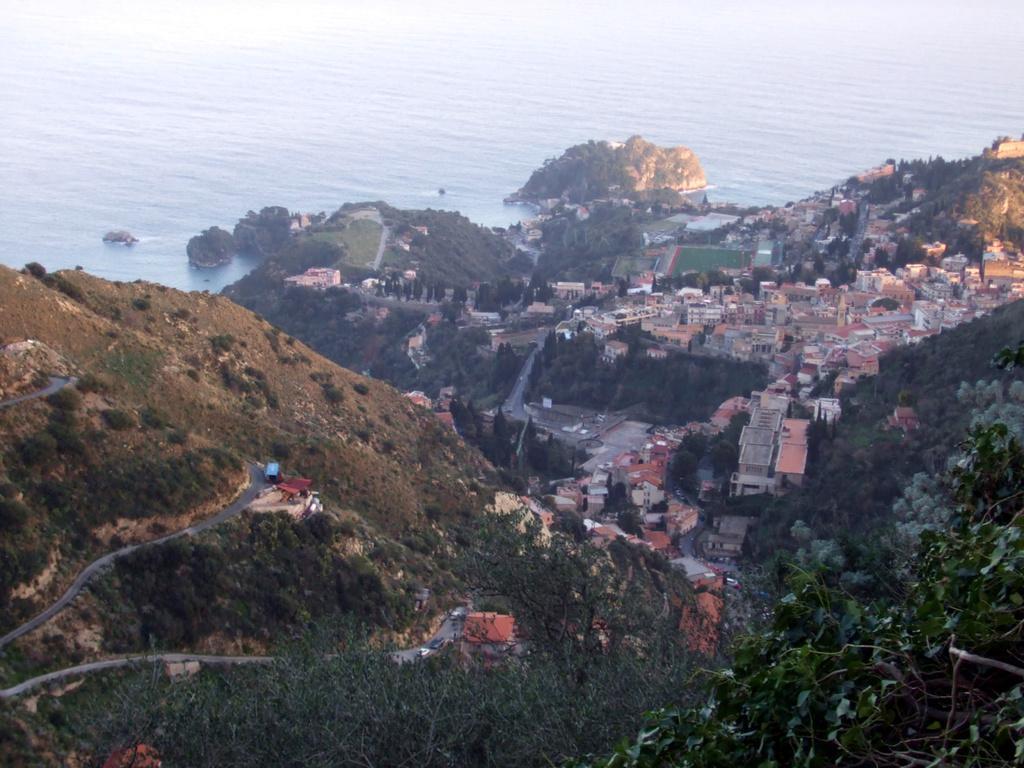In one or two sentences, can you explain what this image depicts? In this image we can see a group of buildings, trees, pathways, the hills and a large water body. 